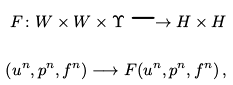<formula> <loc_0><loc_0><loc_500><loc_500>F \colon W \times W \times \Upsilon \longrightarrow H \times H \\ \left ( u ^ { n } , p ^ { n } , f ^ { n } \right ) \longrightarrow F ( u ^ { n } , p ^ { n } , f ^ { n } ) \, ,</formula> 